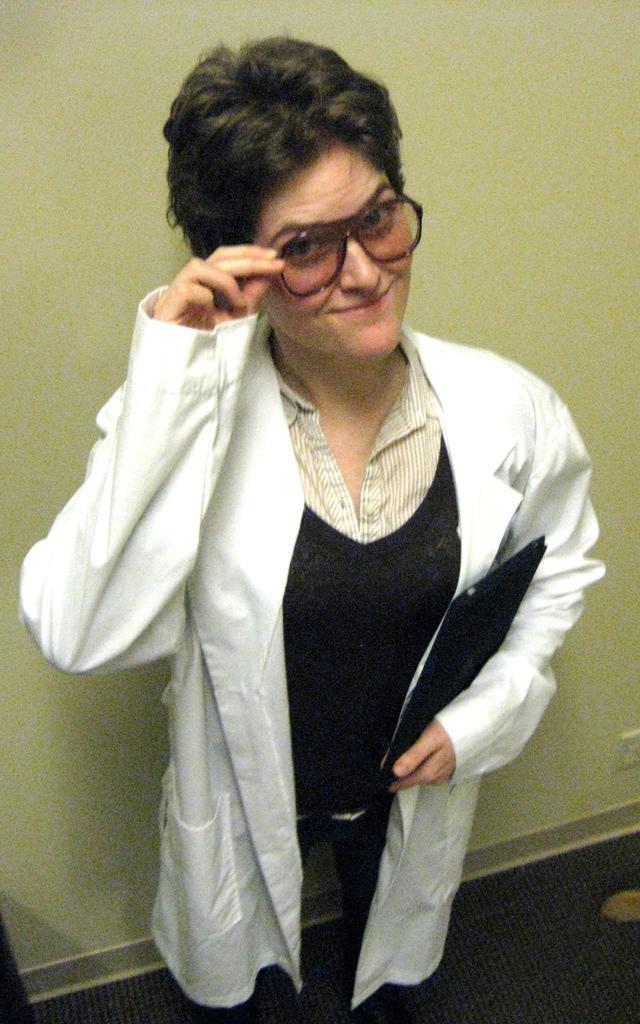Please provide a concise description of this image. In this image I can see a woman wearing white and black colored dress is standing and holding a black colored object and spectacles. In the background I can see the cream colored wall. 